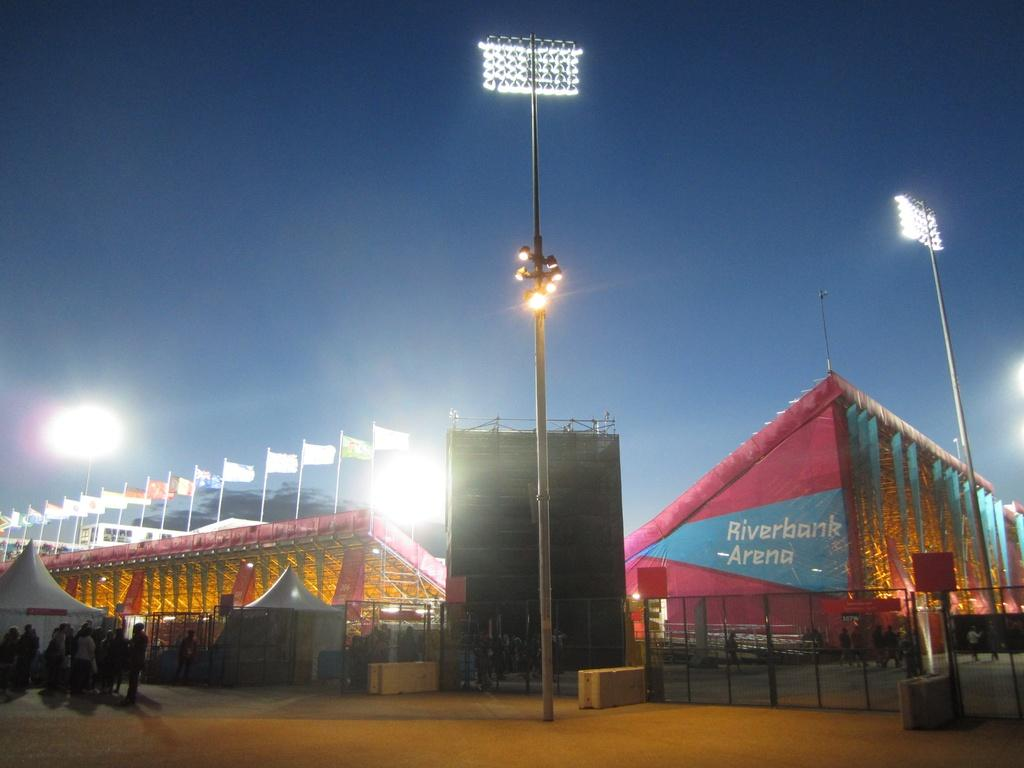What type of structure is the main subject of the image? There is a stadium in the image. What features can be seen within the stadium? There are gates, floodlights, flags, poles, tents, and people visible in the stadium. What is the purpose of the floodlights in the stadium? The floodlights are likely used for illuminating the stadium during nighttime events. What can be seen in the sky in the image? The sky is visible in the image. What color is the cow that is grazing in the stadium? There is no cow present in the image; the main subject is a stadium with various features and objects. 